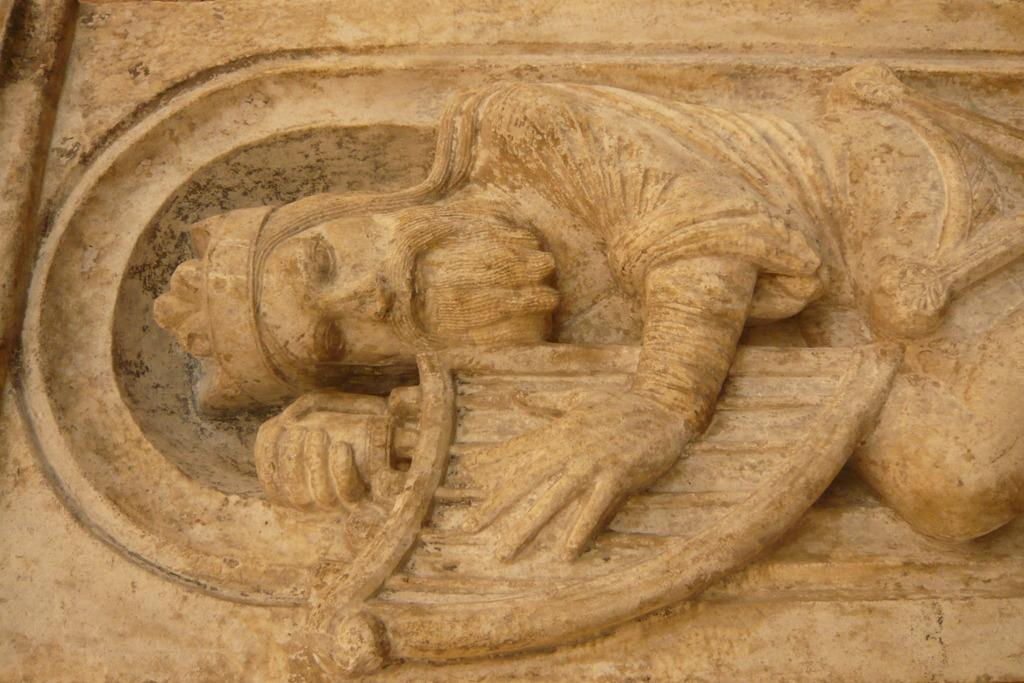What is the main subject of the image? There is a stone carving in the center of the image. What does the stone carving depict? The stone carving depicts a person. What is the person holding in the stone carving? The person is holding an object. What type of appliance can be seen in the stone carving? There is no appliance present in the stone carving; it depicts a person holding an object. Can you describe the person's ability to jump in the stone carving? The stone carving does not depict the person jumping; it shows them standing and holding an object. 